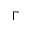Convert formula to latex. <formula><loc_0><loc_0><loc_500><loc_500>\Gamma</formula> 